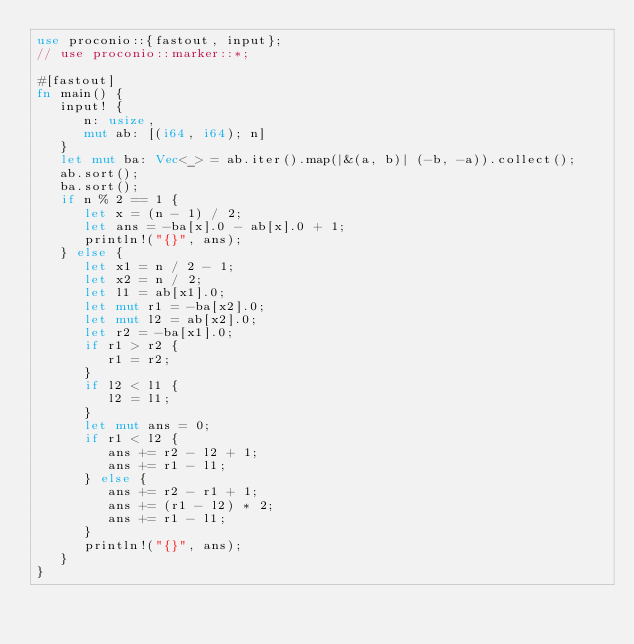Convert code to text. <code><loc_0><loc_0><loc_500><loc_500><_Rust_>use proconio::{fastout, input};
// use proconio::marker::*;

#[fastout]
fn main() {
   input! {
      n: usize,
      mut ab: [(i64, i64); n]
   }
   let mut ba: Vec<_> = ab.iter().map(|&(a, b)| (-b, -a)).collect();
   ab.sort();
   ba.sort();
   if n % 2 == 1 {
      let x = (n - 1) / 2;
      let ans = -ba[x].0 - ab[x].0 + 1;
      println!("{}", ans);
   } else {
      let x1 = n / 2 - 1;
      let x2 = n / 2;
      let l1 = ab[x1].0;
      let mut r1 = -ba[x2].0;
      let mut l2 = ab[x2].0;
      let r2 = -ba[x1].0;
      if r1 > r2 {
         r1 = r2;
      }
      if l2 < l1 {
         l2 = l1;
      }
      let mut ans = 0;
      if r1 < l2 {
         ans += r2 - l2 + 1;
         ans += r1 - l1;
      } else {
         ans += r2 - r1 + 1;
         ans += (r1 - l2) * 2;
         ans += r1 - l1;
      }
      println!("{}", ans);
   }
}
</code> 